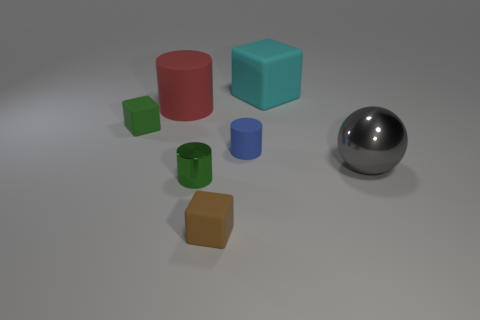Is there another green rubber object that has the same size as the green matte object?
Give a very brief answer. No. How many brown things have the same shape as the big red matte object?
Your answer should be compact. 0. Are there an equal number of tiny brown rubber cubes that are behind the brown matte block and big red things left of the large metallic ball?
Offer a very short reply. No. Are there any big green matte objects?
Offer a very short reply. No. There is a rubber thing that is in front of the small matte thing to the right of the small cube on the right side of the small green cube; what size is it?
Your answer should be compact. Small. What is the shape of the red thing that is the same size as the gray sphere?
Ensure brevity in your answer.  Cylinder. How many objects are either small cubes behind the small brown object or small red cubes?
Provide a succinct answer. 1. There is a big matte thing that is on the left side of the object that is in front of the tiny green cylinder; are there any green objects that are left of it?
Offer a very short reply. Yes. What number of gray objects are there?
Provide a short and direct response. 1. How many things are big things that are in front of the large matte cube or matte cubes that are to the right of the large cylinder?
Give a very brief answer. 4. 